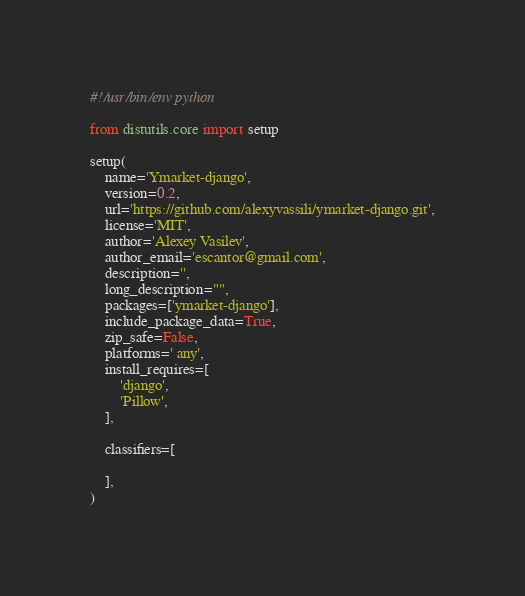<code> <loc_0><loc_0><loc_500><loc_500><_Python_>#!/usr/bin/env python

from distutils.core import setup

setup(
    name='Ymarket-django',
    version=0.2,
    url='https://github.com/alexyvassili/ymarket-django.git',
    license='MIT',
    author='Alexey Vasilev',
    author_email='escantor@gmail.com',
    description='',
    long_description="",
    packages=['ymarket-django'],
    include_package_data=True,
    zip_safe=False,
    platforms=' any',
    install_requires=[
        'django',
        'Pillow',
    ],

    classifiers=[

    ],
)</code> 